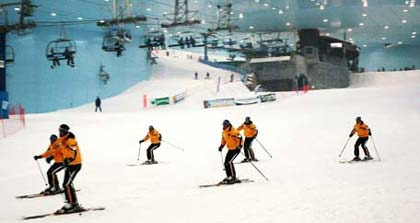Can you tell if it's day or night outside based on the image? Determining whether it is day or night outside based on the indoor image is challenging. Despite the illuminated structures in the background, there is an overall dark ambiance that may suggest it's nighttime. Nevertheless, without a clear view of the outside environment, this remains speculative. 